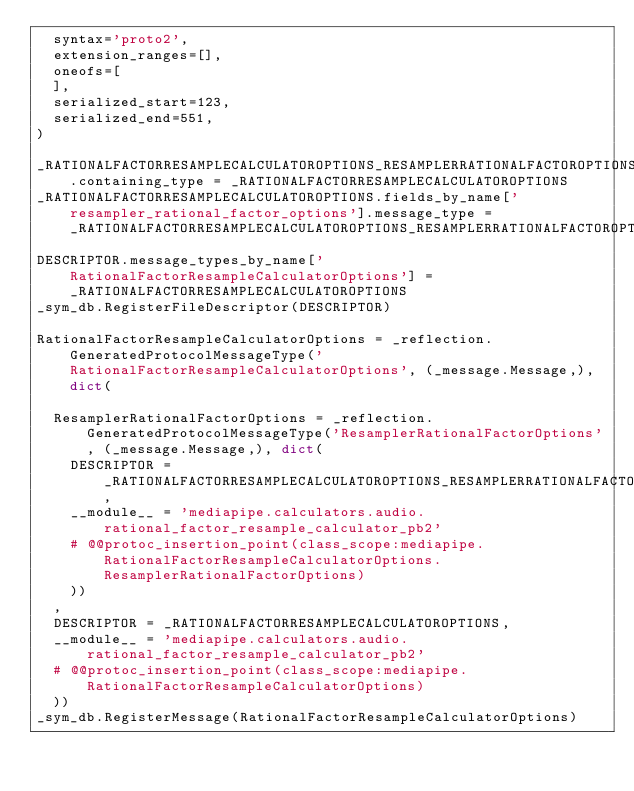Convert code to text. <code><loc_0><loc_0><loc_500><loc_500><_Python_>  syntax='proto2',
  extension_ranges=[],
  oneofs=[
  ],
  serialized_start=123,
  serialized_end=551,
)

_RATIONALFACTORRESAMPLECALCULATOROPTIONS_RESAMPLERRATIONALFACTOROPTIONS.containing_type = _RATIONALFACTORRESAMPLECALCULATOROPTIONS
_RATIONALFACTORRESAMPLECALCULATOROPTIONS.fields_by_name['resampler_rational_factor_options'].message_type = _RATIONALFACTORRESAMPLECALCULATOROPTIONS_RESAMPLERRATIONALFACTOROPTIONS
DESCRIPTOR.message_types_by_name['RationalFactorResampleCalculatorOptions'] = _RATIONALFACTORRESAMPLECALCULATOROPTIONS
_sym_db.RegisterFileDescriptor(DESCRIPTOR)

RationalFactorResampleCalculatorOptions = _reflection.GeneratedProtocolMessageType('RationalFactorResampleCalculatorOptions', (_message.Message,), dict(

  ResamplerRationalFactorOptions = _reflection.GeneratedProtocolMessageType('ResamplerRationalFactorOptions', (_message.Message,), dict(
    DESCRIPTOR = _RATIONALFACTORRESAMPLECALCULATOROPTIONS_RESAMPLERRATIONALFACTOROPTIONS,
    __module__ = 'mediapipe.calculators.audio.rational_factor_resample_calculator_pb2'
    # @@protoc_insertion_point(class_scope:mediapipe.RationalFactorResampleCalculatorOptions.ResamplerRationalFactorOptions)
    ))
  ,
  DESCRIPTOR = _RATIONALFACTORRESAMPLECALCULATOROPTIONS,
  __module__ = 'mediapipe.calculators.audio.rational_factor_resample_calculator_pb2'
  # @@protoc_insertion_point(class_scope:mediapipe.RationalFactorResampleCalculatorOptions)
  ))
_sym_db.RegisterMessage(RationalFactorResampleCalculatorOptions)</code> 